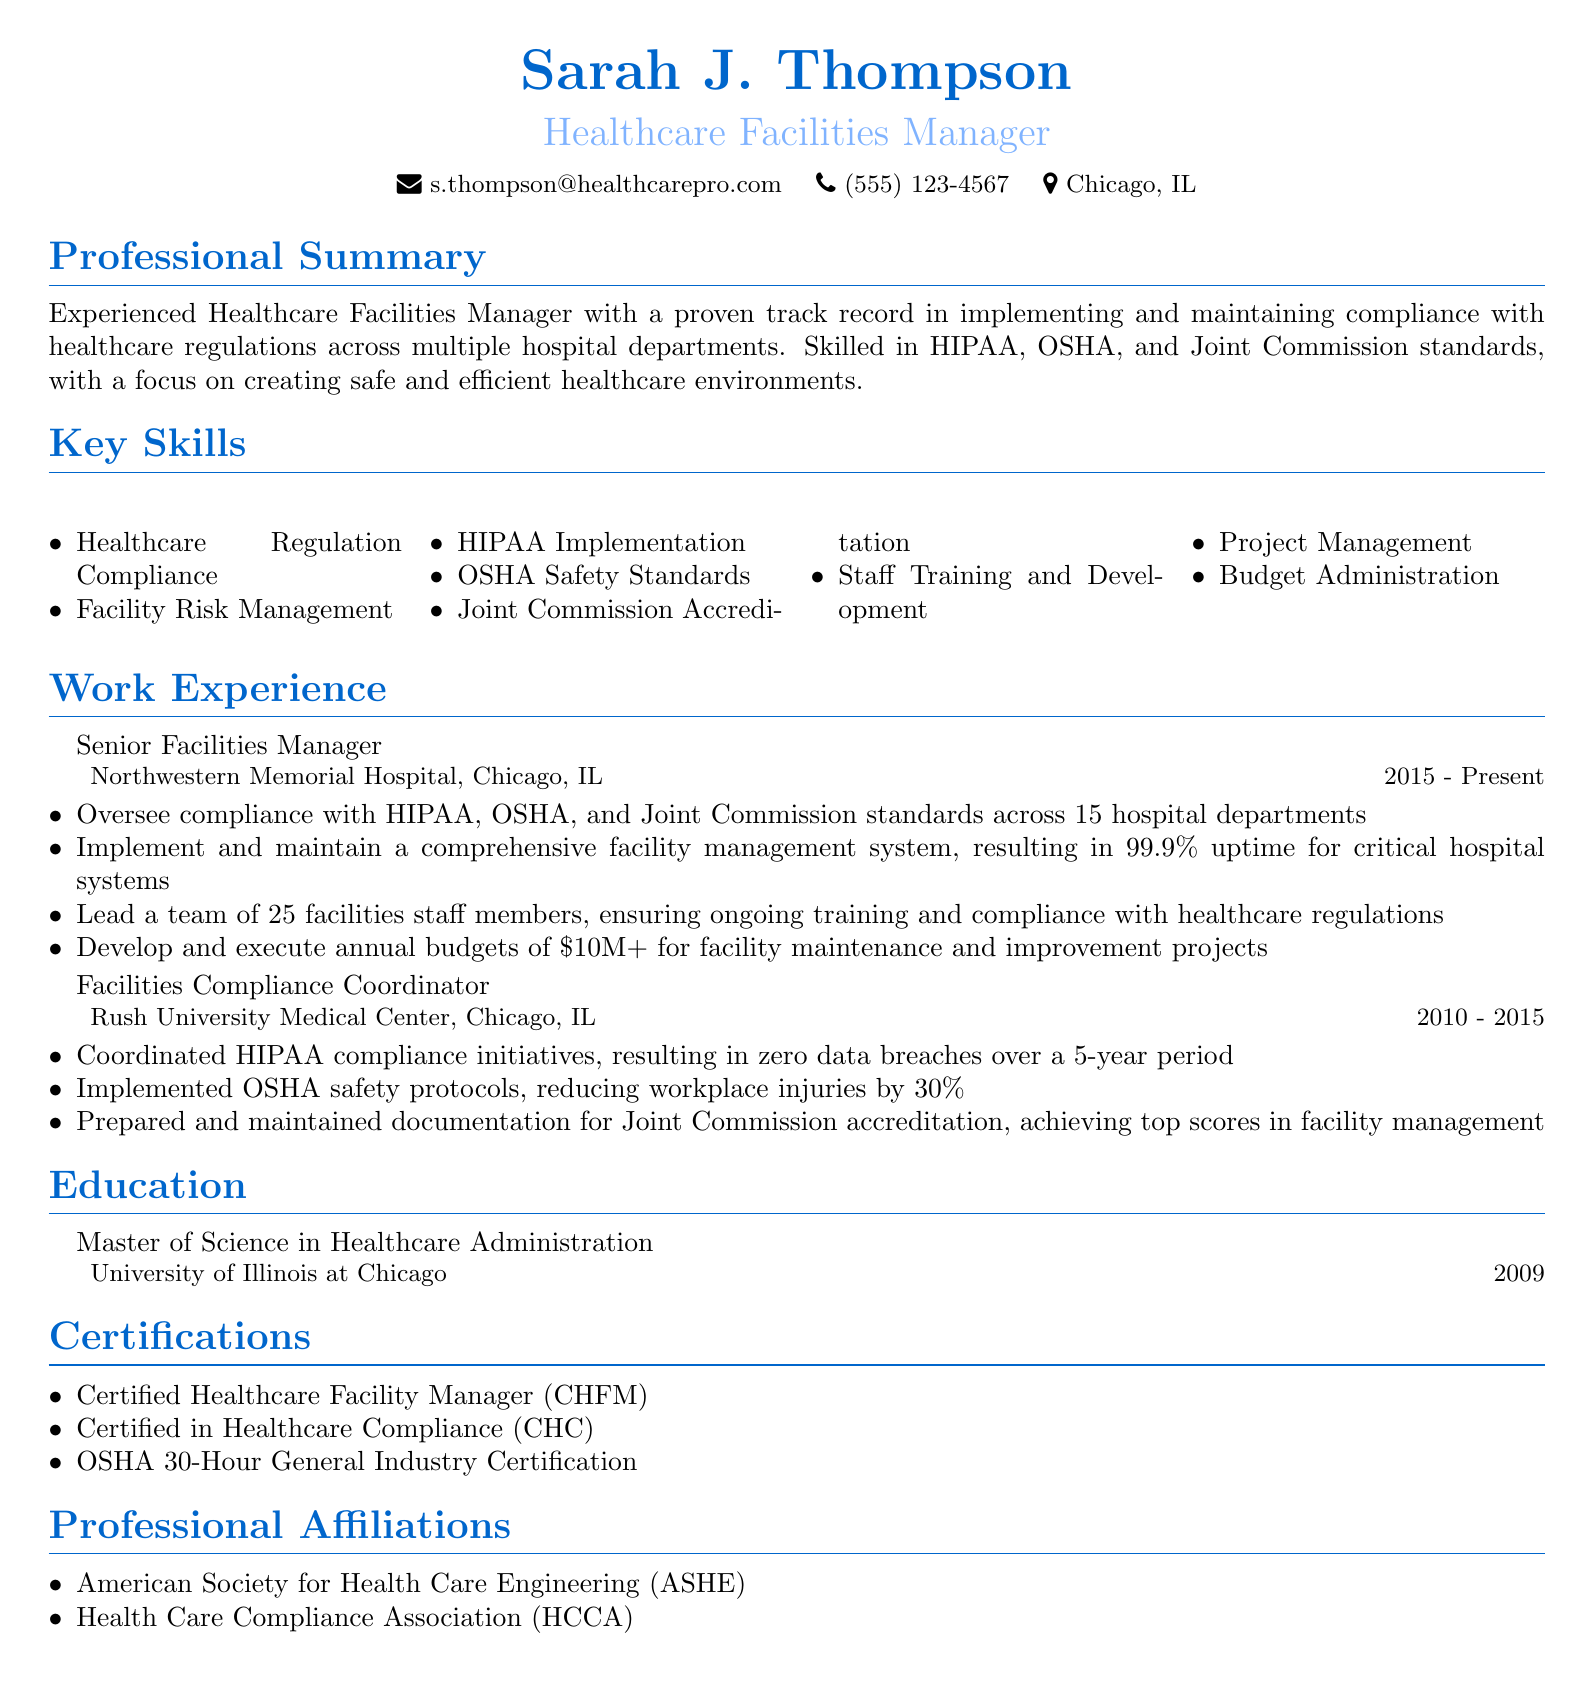What is Sarah J. Thompson's title? The title listed in the document is "Healthcare Facilities Manager."
Answer: Healthcare Facilities Manager Which hospital does Sarah currently work for? The document states that she works at "Northwestern Memorial Hospital."
Answer: Northwestern Memorial Hospital What is the duration of Sarah's current position? The duration listed in the document for her current role is from 2015 to Present.
Answer: 2015 - Present How many hospital departments does she oversee compliance for? The document mentions that she oversees compliance across "15 hospital departments."
Answer: 15 What was the reduction in workplace injuries during Sarah's tenure at Rush University Medical Center? The document states a 30% reduction in workplace injuries due to implemented safety protocols.
Answer: 30% What is the total annual budget Sarah manages? The document indicates she develops and executes annual budgets of over $10M for facility projects.
Answer: $10M+ Which certification indicates Sarah's compliance expertise? "Certified in Healthcare Compliance (CHC)" is mentioned as one of her certifications.
Answer: Certified in Healthcare Compliance (CHC) In which city is Sarah located? The document specifies that Sarah is located in "Chicago, IL."
Answer: Chicago, IL Which professional organization is Sarah affiliated with? The document lists her affiliation with the "American Society for Health Care Engineering (ASHE)."
Answer: American Society for Health Care Engineering (ASHE) 